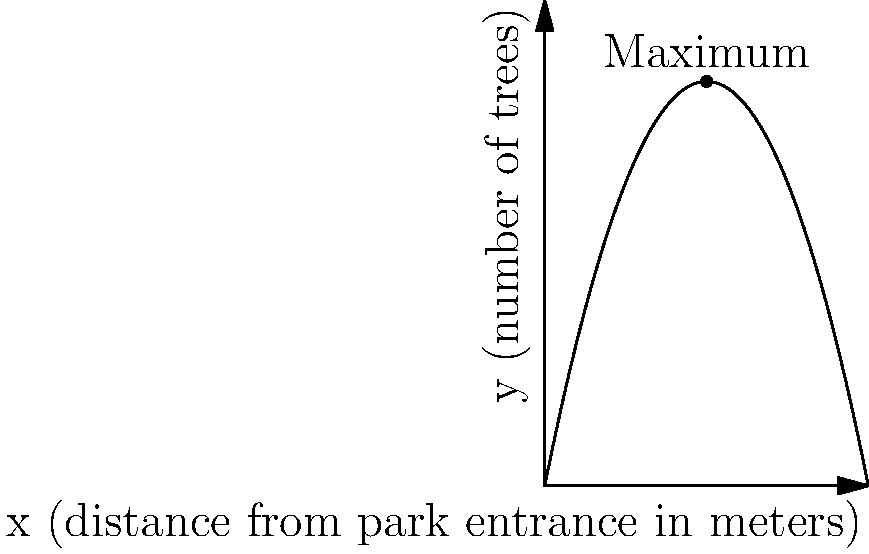As a retired arborist, you've been asked to consult on a tree planting project for a new linear park. The park planners want to maximize the number of trees planted while considering visitor experience. They've modeled the relationship between the number of trees (y) and the distance from the park entrance (x) in meters using the polynomial function: $y = -0.25x^2 + 5x$. At what distance from the park entrance should the maximum number of trees be planted, and how many trees should be planted at this point? To solve this problem, we need to follow these steps:

1) The function given is $y = -0.25x^2 + 5x$, which is a quadratic function (a parabola).

2) To find the maximum point of a parabola, we need to find its vertex. For a quadratic function in the form $y = ax^2 + bx + c$, the x-coordinate of the vertex is given by $x = -\frac{b}{2a}$.

3) In our case, $a = -0.25$ and $b = 5$. Let's substitute these values:

   $x = -\frac{5}{2(-0.25)} = -\frac{5}{-0.5} = 10$

4) This means the maximum number of trees should be planted 10 meters from the park entrance.

5) To find how many trees should be planted at this point, we need to substitute x = 10 into our original function:

   $y = -0.25(10)^2 + 5(10)$
   $y = -0.25(100) + 50$
   $y = -25 + 50 = 25$

Therefore, the maximum number of trees (25) should be planted 10 meters from the park entrance.
Answer: 10 meters from entrance, 25 trees 